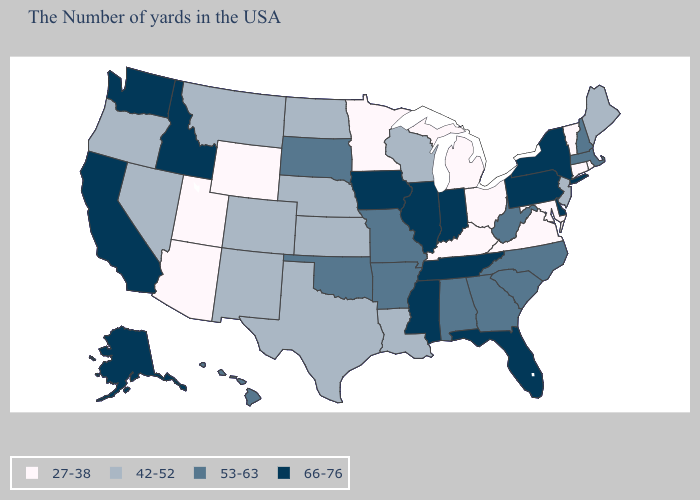Does the first symbol in the legend represent the smallest category?
Answer briefly. Yes. Does the map have missing data?
Quick response, please. No. Does Rhode Island have the lowest value in the Northeast?
Write a very short answer. Yes. Is the legend a continuous bar?
Short answer required. No. Name the states that have a value in the range 27-38?
Answer briefly. Rhode Island, Vermont, Connecticut, Maryland, Virginia, Ohio, Michigan, Kentucky, Minnesota, Wyoming, Utah, Arizona. Name the states that have a value in the range 27-38?
Keep it brief. Rhode Island, Vermont, Connecticut, Maryland, Virginia, Ohio, Michigan, Kentucky, Minnesota, Wyoming, Utah, Arizona. Name the states that have a value in the range 66-76?
Give a very brief answer. New York, Delaware, Pennsylvania, Florida, Indiana, Tennessee, Illinois, Mississippi, Iowa, Idaho, California, Washington, Alaska. Among the states that border Kentucky , which have the lowest value?
Keep it brief. Virginia, Ohio. Does the first symbol in the legend represent the smallest category?
Be succinct. Yes. What is the value of Arkansas?
Concise answer only. 53-63. Which states hav the highest value in the MidWest?
Give a very brief answer. Indiana, Illinois, Iowa. What is the value of Mississippi?
Write a very short answer. 66-76. Name the states that have a value in the range 42-52?
Give a very brief answer. Maine, New Jersey, Wisconsin, Louisiana, Kansas, Nebraska, Texas, North Dakota, Colorado, New Mexico, Montana, Nevada, Oregon. Does Pennsylvania have the same value as Missouri?
Be succinct. No. What is the value of Alaska?
Keep it brief. 66-76. 